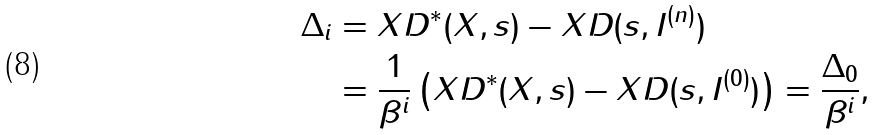Convert formula to latex. <formula><loc_0><loc_0><loc_500><loc_500>\Delta _ { i } & = X D ^ { * } ( X , s ) - X D ( s , I ^ { ( n ) } ) \\ & = \frac { 1 } { \beta ^ { i } } \left ( X D ^ { * } ( X , s ) - X D ( s , I ^ { ( 0 ) } ) \right ) = \frac { \Delta _ { 0 } } { \beta ^ { i } } ,</formula> 